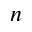Convert formula to latex. <formula><loc_0><loc_0><loc_500><loc_500>n</formula> 